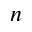Convert formula to latex. <formula><loc_0><loc_0><loc_500><loc_500>n</formula> 